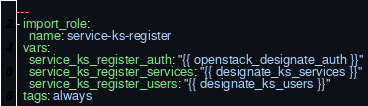Convert code to text. <code><loc_0><loc_0><loc_500><loc_500><_YAML_>---
- import_role:
    name: service-ks-register
  vars:
    service_ks_register_auth: "{{ openstack_designate_auth }}"
    service_ks_register_services: "{{ designate_ks_services }}"
    service_ks_register_users: "{{ designate_ks_users }}"
  tags: always
</code> 